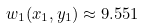<formula> <loc_0><loc_0><loc_500><loc_500>w _ { 1 } ( x _ { 1 } , y _ { 1 } ) \approx 9 . 5 5 1</formula> 